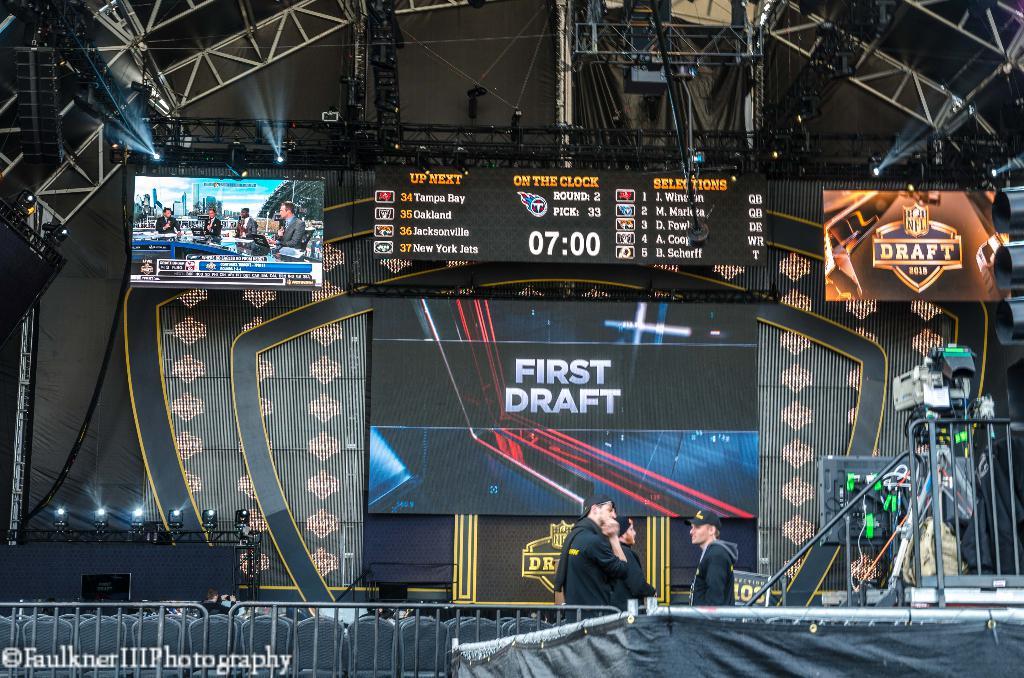What time is it?
Your answer should be very brief. 7:00. 